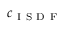Convert formula to latex. <formula><loc_0><loc_0><loc_500><loc_500>c _ { I S D F }</formula> 